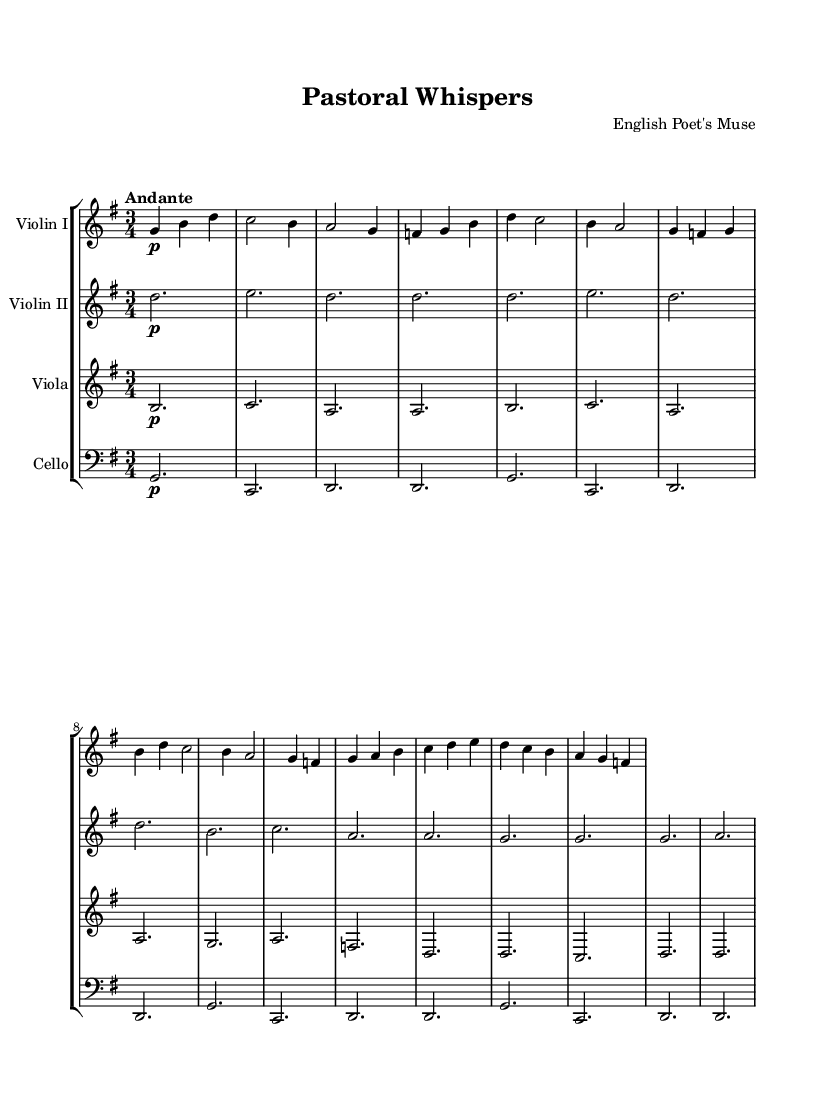What is the key signature of this music? The key signature indicates that there is one sharp (F#) in the music, which is characteristic of G major.
Answer: G major What is the time signature of the piece? The time signature displayed at the beginning of the score denotes that there are three beats in a measure, making it a waltz-like rhythm.
Answer: 3/4 What is the tempo marking given in the score? The tempo marking specifies the speed at which the piece should be played, indicating a moderate pace with the instruction "Andante."
Answer: Andante How many instruments are involved in this piece? By counting the individual staves provided in the score, it can be determined that there are four distinct instruments represented.
Answer: Four What is the dynamics marking at the beginning of the first theme? The dynamics marking indicates the volume at which the music should be played, and in this case, it indicates playing softly right from the start.
Answer: Pianissimo Which instrument plays the introduction in the score? The introduction is found in the first section, where it is implied that the upper voices, particularly Violin I, carry the main thematic material.
Answer: Violin I Is there a recurring theme in the piece, and if so, what is its nature? Observing the score, we can see repeated motifs and phrases, suggesting an evolving theme that reflects a pastoral essence typical of English poetry.
Answer: Yes, evolving theme 